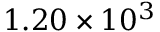Convert formula to latex. <formula><loc_0><loc_0><loc_500><loc_500>1 . 2 0 \times 1 0 ^ { 3 }</formula> 